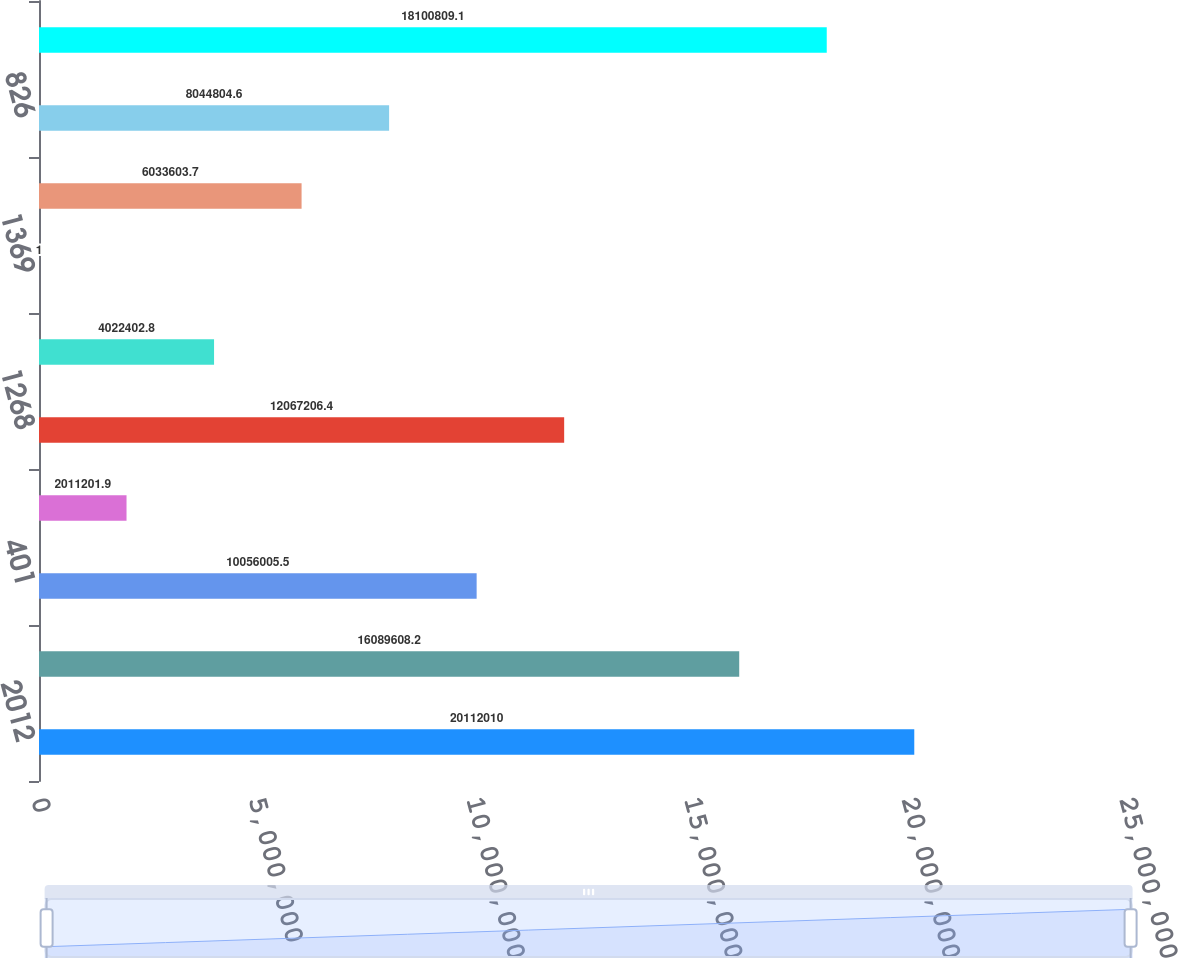<chart> <loc_0><loc_0><loc_500><loc_500><bar_chart><fcel>2012<fcel>4967<fcel>401<fcel>507<fcel>1268<fcel>1162<fcel>1369<fcel>770<fcel>826<fcel>956<nl><fcel>2.0112e+07<fcel>1.60896e+07<fcel>1.0056e+07<fcel>2.0112e+06<fcel>1.20672e+07<fcel>4.0224e+06<fcel>1<fcel>6.0336e+06<fcel>8.0448e+06<fcel>1.81008e+07<nl></chart> 